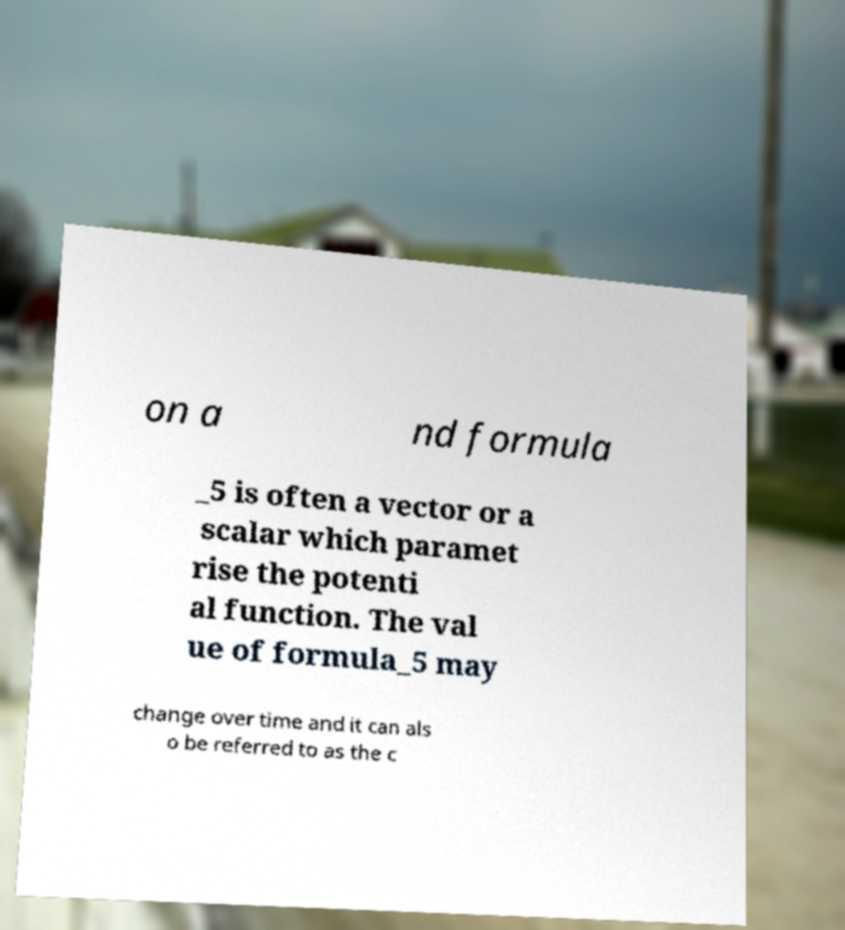Could you extract and type out the text from this image? on a nd formula _5 is often a vector or a scalar which paramet rise the potenti al function. The val ue of formula_5 may change over time and it can als o be referred to as the c 